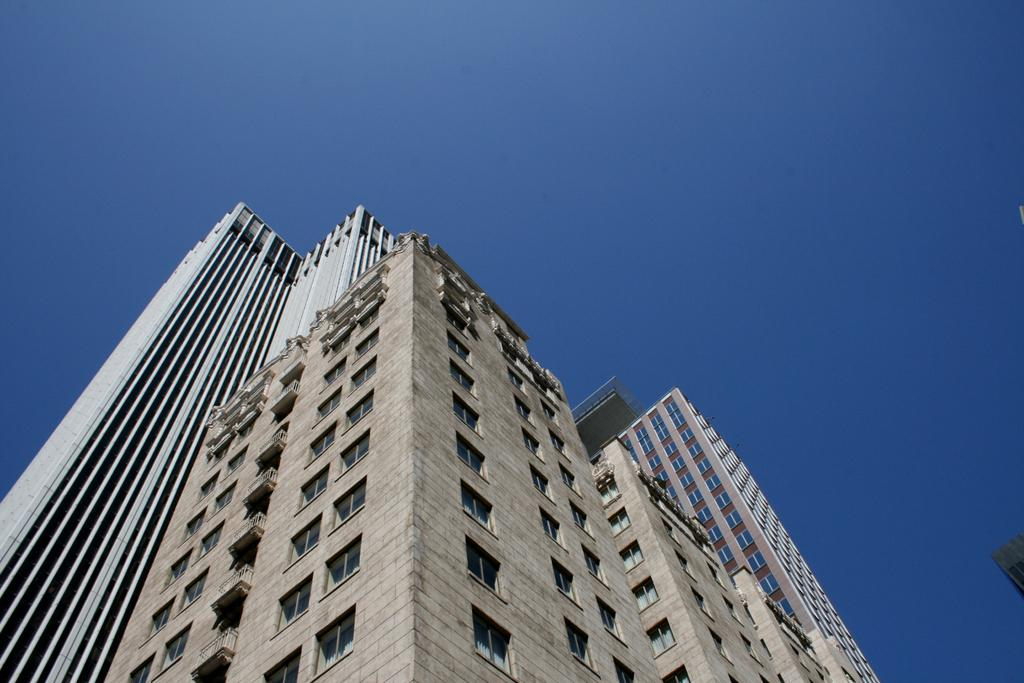Where was the image taken from? The image was taken from the outside of a building. What can be seen in the image besides the building? There is a window and the sky visible in the image. What is the color of the sky in the image? The sky is blue in color. What type of flight is being exchanged between the campers in the image? There are no campers or flights present in the image; it features a building, a window, and a blue sky. 